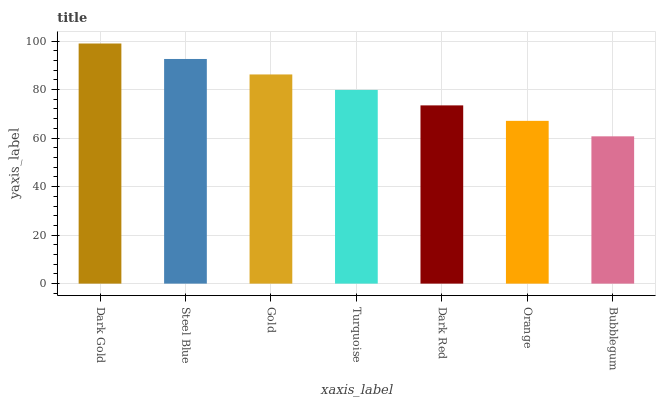Is Bubblegum the minimum?
Answer yes or no. Yes. Is Dark Gold the maximum?
Answer yes or no. Yes. Is Steel Blue the minimum?
Answer yes or no. No. Is Steel Blue the maximum?
Answer yes or no. No. Is Dark Gold greater than Steel Blue?
Answer yes or no. Yes. Is Steel Blue less than Dark Gold?
Answer yes or no. Yes. Is Steel Blue greater than Dark Gold?
Answer yes or no. No. Is Dark Gold less than Steel Blue?
Answer yes or no. No. Is Turquoise the high median?
Answer yes or no. Yes. Is Turquoise the low median?
Answer yes or no. Yes. Is Dark Red the high median?
Answer yes or no. No. Is Gold the low median?
Answer yes or no. No. 